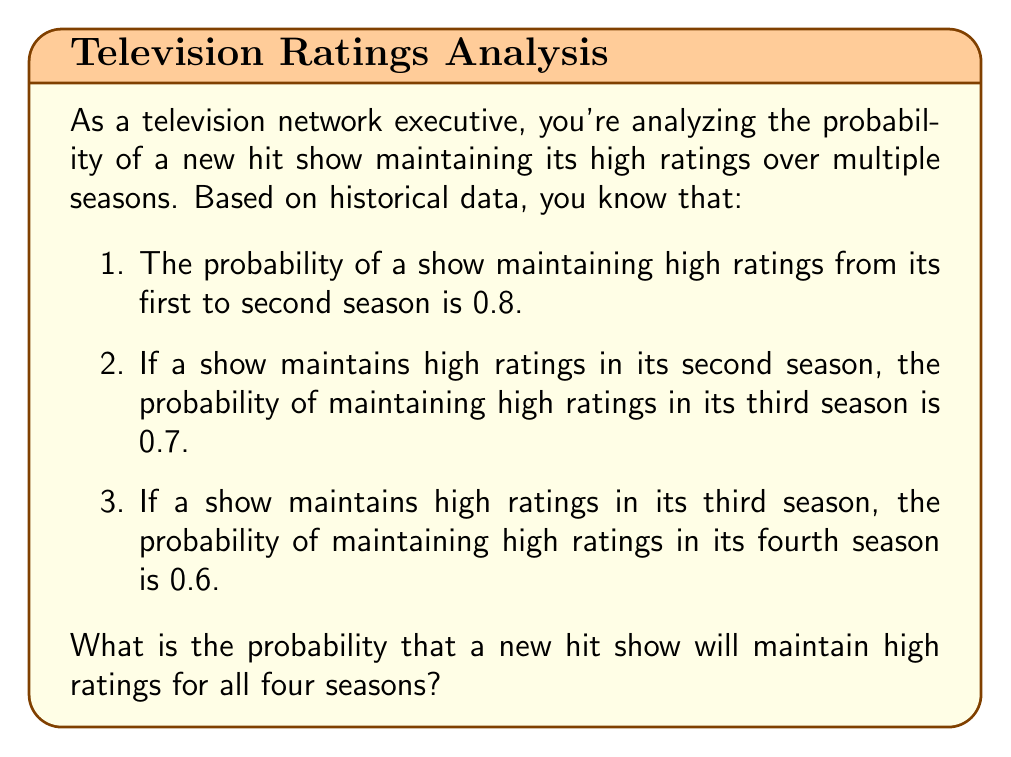Can you solve this math problem? To solve this problem, we need to use the concept of conditional probability and the multiplication rule for independent events.

Let's define the events:
$A$: Show maintains high ratings from first to second season
$B$: Show maintains high ratings from second to third season
$C$: Show maintains high ratings from third to fourth season

We're given:
$P(A) = 0.8$
$P(B|A) = 0.7$
$P(C|B) = 0.6$

To find the probability of maintaining high ratings for all four seasons, we need to calculate $P(A \cap B \cap C)$.

Using the multiplication rule:

$$P(A \cap B \cap C) = P(A) \cdot P(B|A) \cdot P(C|B)$$

Substituting the given probabilities:

$$P(A \cap B \cap C) = 0.8 \cdot 0.7 \cdot 0.6$$

Calculating:

$$P(A \cap B \cap C) = 0.336$$

Therefore, the probability that a new hit show will maintain high ratings for all four seasons is 0.336 or 33.6%.
Answer: 0.336 or 33.6% 